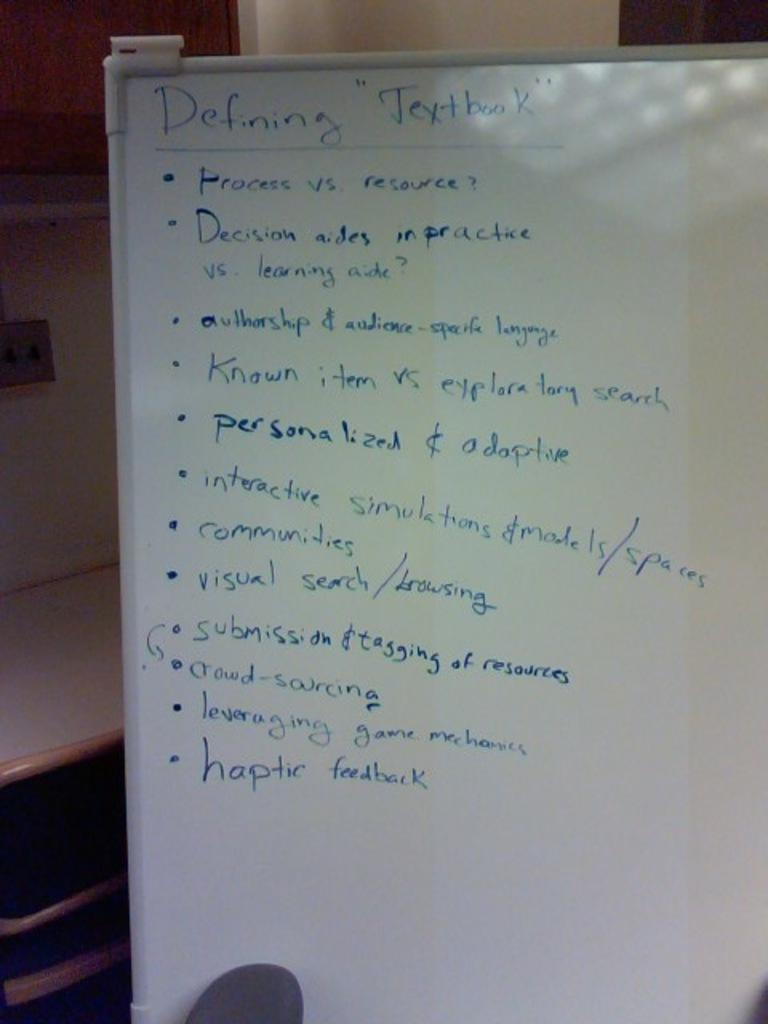<image>
Summarize the visual content of the image. Whiteboard with blue letters that says "Defining Textbook" on the top. 